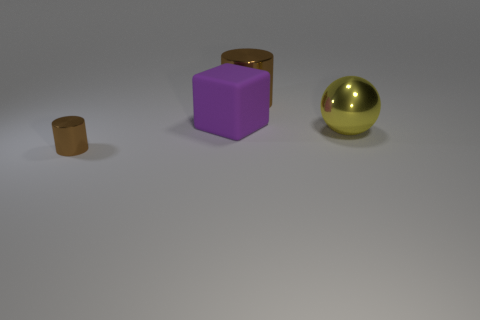There is another metal object that is the same color as the tiny object; what is its shape?
Give a very brief answer. Cylinder. What is the thing that is both in front of the purple rubber thing and on the right side of the tiny brown metal cylinder made of?
Your response must be concise. Metal. Is the number of yellow shiny objects less than the number of brown cylinders?
Offer a very short reply. Yes. Does the big yellow metallic object have the same shape as the brown thing in front of the large cylinder?
Make the answer very short. No. Is the size of the brown cylinder that is in front of the rubber object the same as the large purple matte object?
Your answer should be very brief. No. What is the shape of the brown thing that is the same size as the purple rubber block?
Your answer should be very brief. Cylinder. Does the big brown metal object have the same shape as the large yellow object?
Provide a short and direct response. No. How many other large brown things have the same shape as the matte thing?
Provide a succinct answer. 0. There is a matte object; how many brown cylinders are behind it?
Make the answer very short. 1. There is a cylinder that is behind the large ball; is it the same color as the sphere?
Offer a very short reply. No. 